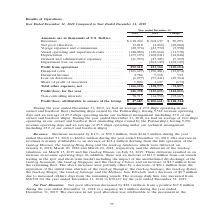From Gaslog's financial document, How many ships on average are operating in 2019 and 2018 respectively? The document shows two values: 27.2 ships and 26.0 ships. From the document: "ear ended December 31, 2018, we had an average of 26.0 ships operating in our owned and bareboat fleet (including ships owned by the Partnership), hav..." Also, What was the change in revenue from 2018 to 2019? According to the financial document, $50.3 million. The relevant text states: "Revenues: Revenues increased by 8.1%, or $50.3 million, from $618.3 million during the year ended December 31, 2018 to $668.6 million during the year ende..." Also, What was the total revenue operating days in 2019? According to the financial document, 9,518. The relevant text states: "including ships owned by the Partnership), having 9,518 revenue operating days and an average of 27.2 ships operating under our technical management (inclu..." Additionally, Which year has a higher revenue? According to the financial document, 2019. The relevant text states: "Year ended December 31, 2018 2019 Change..." Also, can you calculate: What was the percentage change in profit from operations from 2018 to 2019? To answer this question, I need to perform calculations using the financial data. The calculation is: (123,364 - 292,518)/292,518 , which equals -57.83 (percentage). This is based on the information: "Profit from operations . 292,518 123,364 (169,154) Profit from operations . 292,518 123,364 (169,154)..." The key data points involved are: 123,364, 292,518. Also, can you calculate: What was the change in average daily hire rate from 2018 to 2019? Based on the calculation: $70,167 - $68,392 , the result is 1775. This is based on the information: "$68,392 for the year ended December 31, 2018 to $70,167 for the year ended December 31, 2019. sels. The average daily hire rate increased from $68,392 for the year ended December 31, 2018 to $70,167 f..." The key data points involved are: 68,392, 70,167. 